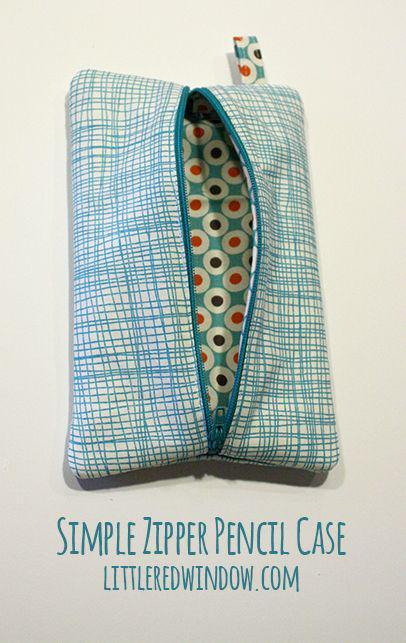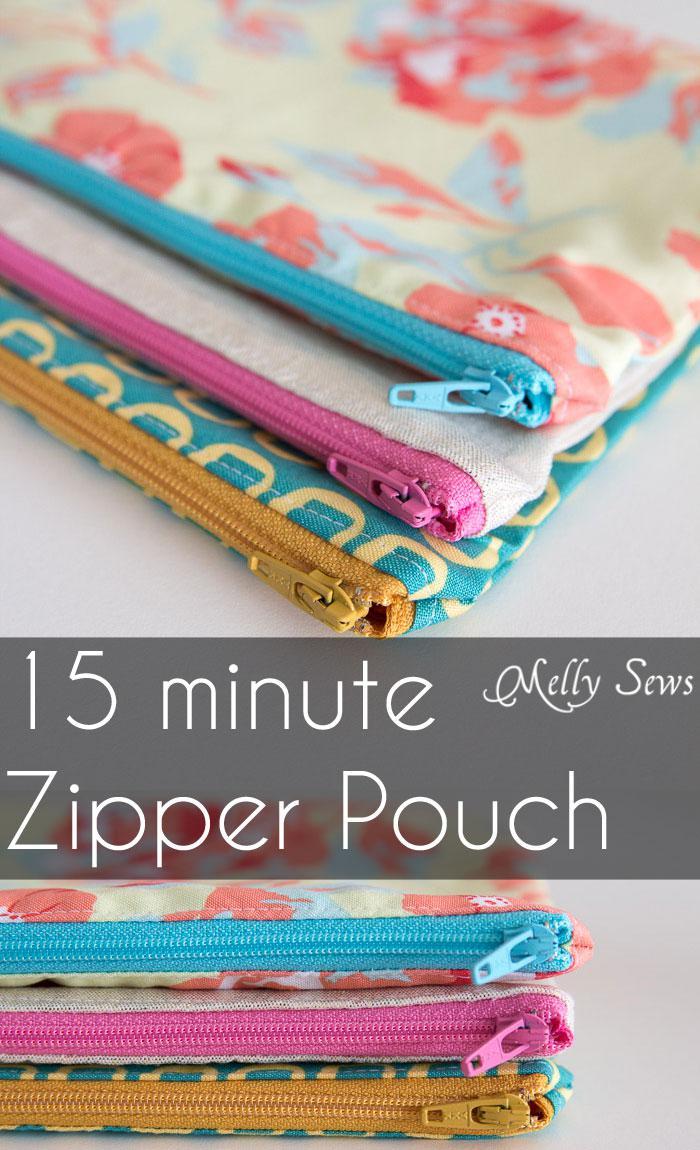The first image is the image on the left, the second image is the image on the right. Considering the images on both sides, is "There are at least 3 zipper pouches in the right image." valid? Answer yes or no. Yes. 